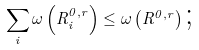<formula> <loc_0><loc_0><loc_500><loc_500>\sum _ { i } \omega \left ( R _ { i } ^ { 0 , r } \right ) \leq \omega \left ( R ^ { 0 , r } \right ) \text {;}</formula> 